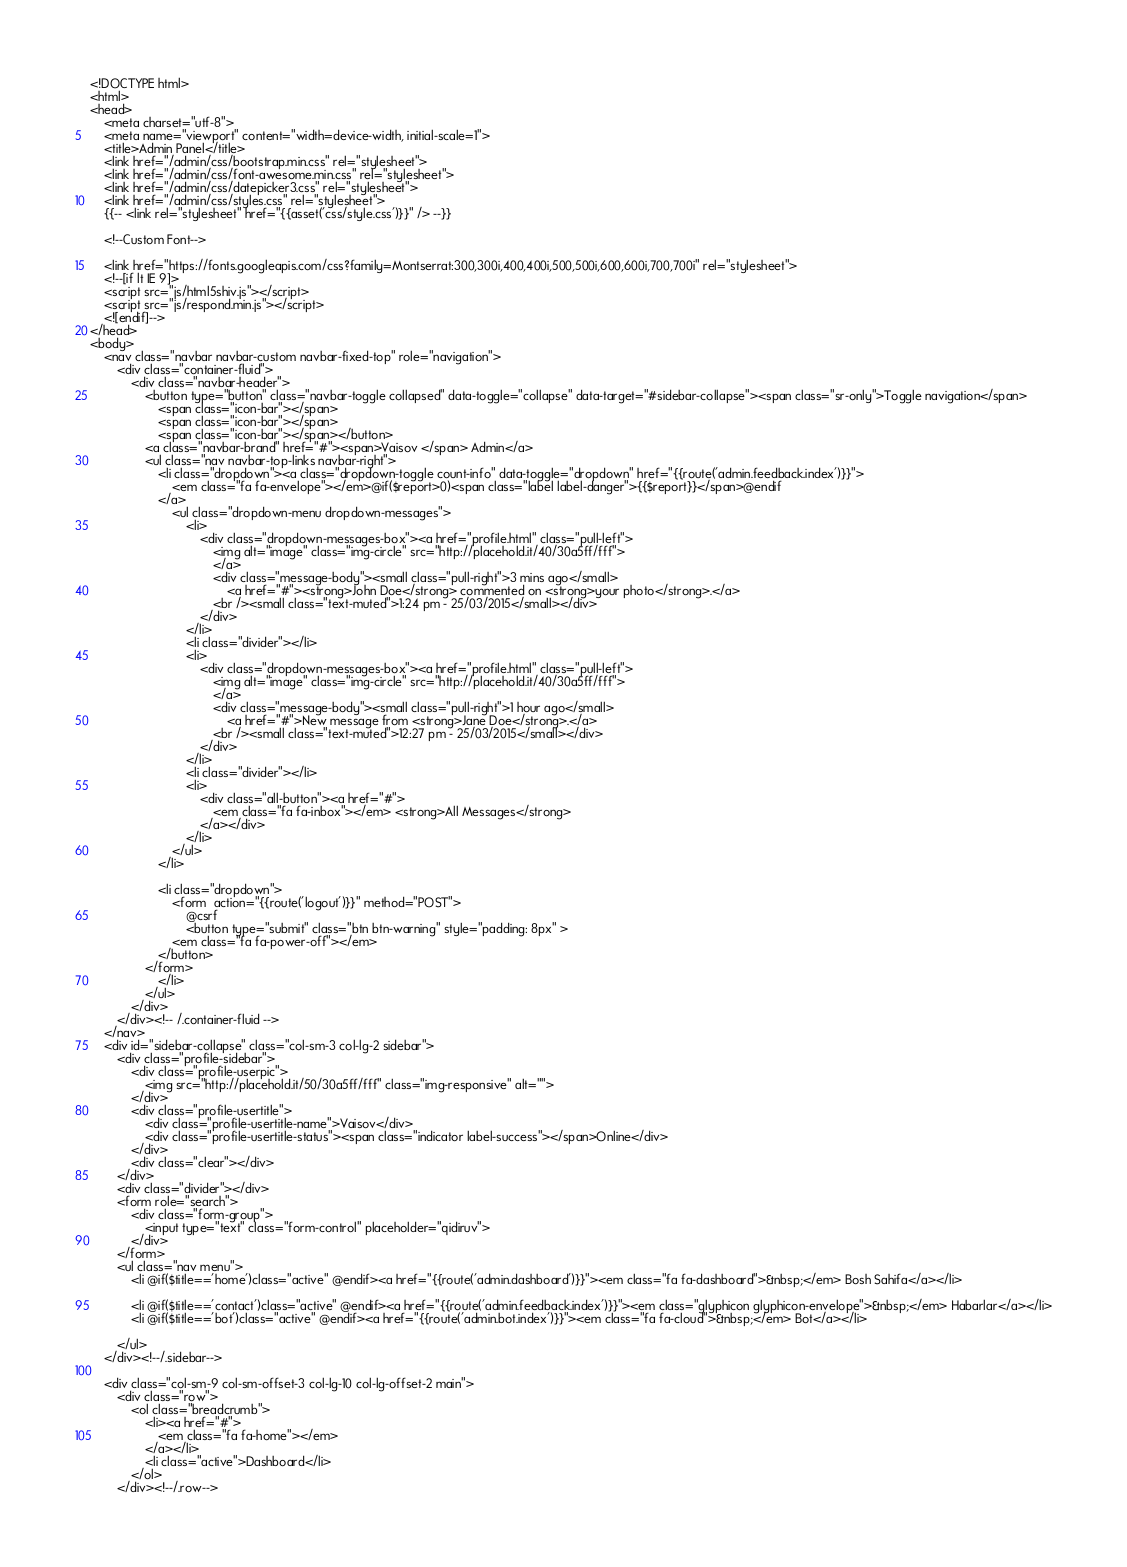Convert code to text. <code><loc_0><loc_0><loc_500><loc_500><_PHP_><!DOCTYPE html>
<html>
<head>
	<meta charset="utf-8">
	<meta name="viewport" content="width=device-width, initial-scale=1">
	<title>Admin Panel</title>
	<link href="/admin/css/bootstrap.min.css" rel="stylesheet">
	<link href="/admin/css/font-awesome.min.css" rel="stylesheet">
	<link href="/admin/css/datepicker3.css" rel="stylesheet">
	<link href="/admin/css/styles.css" rel="stylesheet">
    {{-- <link rel="stylesheet" href="{{asset('css/style.css')}}" /> --}}

	<!--Custom Font-->

	<link href="https://fonts.googleapis.com/css?family=Montserrat:300,300i,400,400i,500,500i,600,600i,700,700i" rel="stylesheet">
	<!--[if lt IE 9]>
	<script src="js/html5shiv.js"></script>
	<script src="js/respond.min.js"></script>
	<![endif]-->
</head>
<body>
	<nav class="navbar navbar-custom navbar-fixed-top" role="navigation">
		<div class="container-fluid">
			<div class="navbar-header">
				<button type="button" class="navbar-toggle collapsed" data-toggle="collapse" data-target="#sidebar-collapse"><span class="sr-only">Toggle navigation</span>
					<span class="icon-bar"></span>
					<span class="icon-bar"></span>
					<span class="icon-bar"></span></button>
				<a class="navbar-brand" href="#"><span>Vaisov </span> Admin</a>
				<ul class="nav navbar-top-links navbar-right">
					<li class="dropdown"><a class="dropdown-toggle count-info" data-toggle="dropdown" href="{{route('admin.feedback.index')}}">
						<em class="fa fa-envelope"></em>@if($report>0)<span class="label label-danger">{{$report}}</span>@endif
					</a>
						<ul class="dropdown-menu dropdown-messages">
							<li>
								<div class="dropdown-messages-box"><a href="profile.html" class="pull-left">
									<img alt="image" class="img-circle" src="http://placehold.it/40/30a5ff/fff">
									</a>
									<div class="message-body"><small class="pull-right">3 mins ago</small>
										<a href="#"><strong>John Doe</strong> commented on <strong>your photo</strong>.</a>
									<br /><small class="text-muted">1:24 pm - 25/03/2015</small></div>
								</div>
							</li>
							<li class="divider"></li>
							<li>
								<div class="dropdown-messages-box"><a href="profile.html" class="pull-left">
									<img alt="image" class="img-circle" src="http://placehold.it/40/30a5ff/fff">
									</a>
									<div class="message-body"><small class="pull-right">1 hour ago</small>
										<a href="#">New message from <strong>Jane Doe</strong>.</a>
									<br /><small class="text-muted">12:27 pm - 25/03/2015</small></div>
								</div>
							</li>
							<li class="divider"></li>
							<li>
								<div class="all-button"><a href="#">
									<em class="fa fa-inbox"></em> <strong>All Messages</strong>
								</a></div>
							</li>
						</ul>
					</li>
					
					<li class="dropdown">
						<form  action="{{route('logout')}}" method="POST">
							@csrf
							<button type="submit" class="btn btn-warning" style="padding: 8px" >
						<em class="fa fa-power-off"></em>
					</button>
				</form>
					</li>
				</ul>
			</div>
		</div><!-- /.container-fluid -->
	</nav>
	<div id="sidebar-collapse" class="col-sm-3 col-lg-2 sidebar">
		<div class="profile-sidebar">
			<div class="profile-userpic">
				<img src="http://placehold.it/50/30a5ff/fff" class="img-responsive" alt="">
			</div>
			<div class="profile-usertitle">
				<div class="profile-usertitle-name">Vaisov</div>
				<div class="profile-usertitle-status"><span class="indicator label-success"></span>Online</div>
			</div>
			<div class="clear"></div>
		</div>
		<div class="divider"></div>
		<form role="search">
			<div class="form-group">
				<input type="text" class="form-control" placeholder="qidiruv">
			</div>
		</form>
		<ul class="nav menu">
			<li @if($title=='home')class="active" @endif><a href="{{route('admin.dashboard')}}"><em class="fa fa-dashboard">&nbsp;</em> Bosh Sahifa</a></li>
			
			<li @if($title=='contact')class="active" @endif><a href="{{route('admin.feedback.index')}}"><em class="glyphicon glyphicon-envelope">&nbsp;</em> Habarlar</a></li>
			<li @if($title=='bot')class="active" @endif><a href="{{route('admin.bot.index')}}"><em class="fa fa-cloud">&nbsp;</em> Bot</a></li>
			
		</ul>
	</div><!--/.sidebar-->

	<div class="col-sm-9 col-sm-offset-3 col-lg-10 col-lg-offset-2 main">
		<div class="row">
			<ol class="breadcrumb">
				<li><a href="#">
					<em class="fa fa-home"></em>
				</a></li>
				<li class="active">Dashboard</li>
			</ol>
		</div><!--/.row-->
</code> 